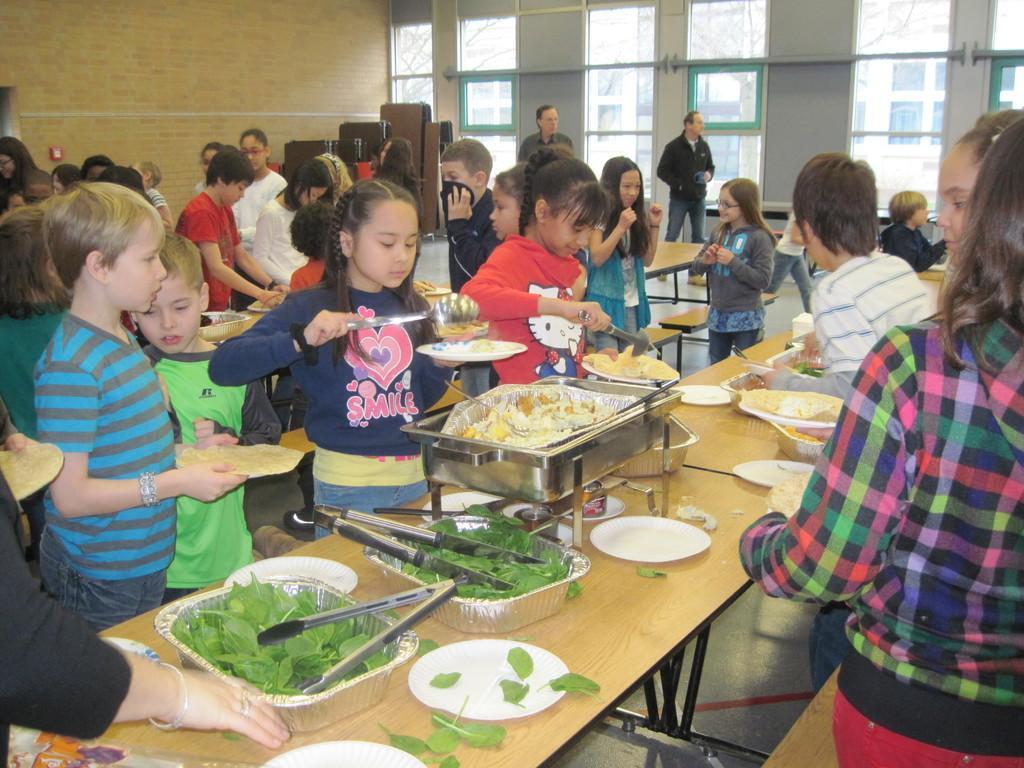Could you give a brief overview of what you see in this image? In this picture we can see a group of children's standing and in front of them on table we have bowls with leaves in it, plate, tray, some food item and in background we can see two men standing, windows, wall, wooden planks. 